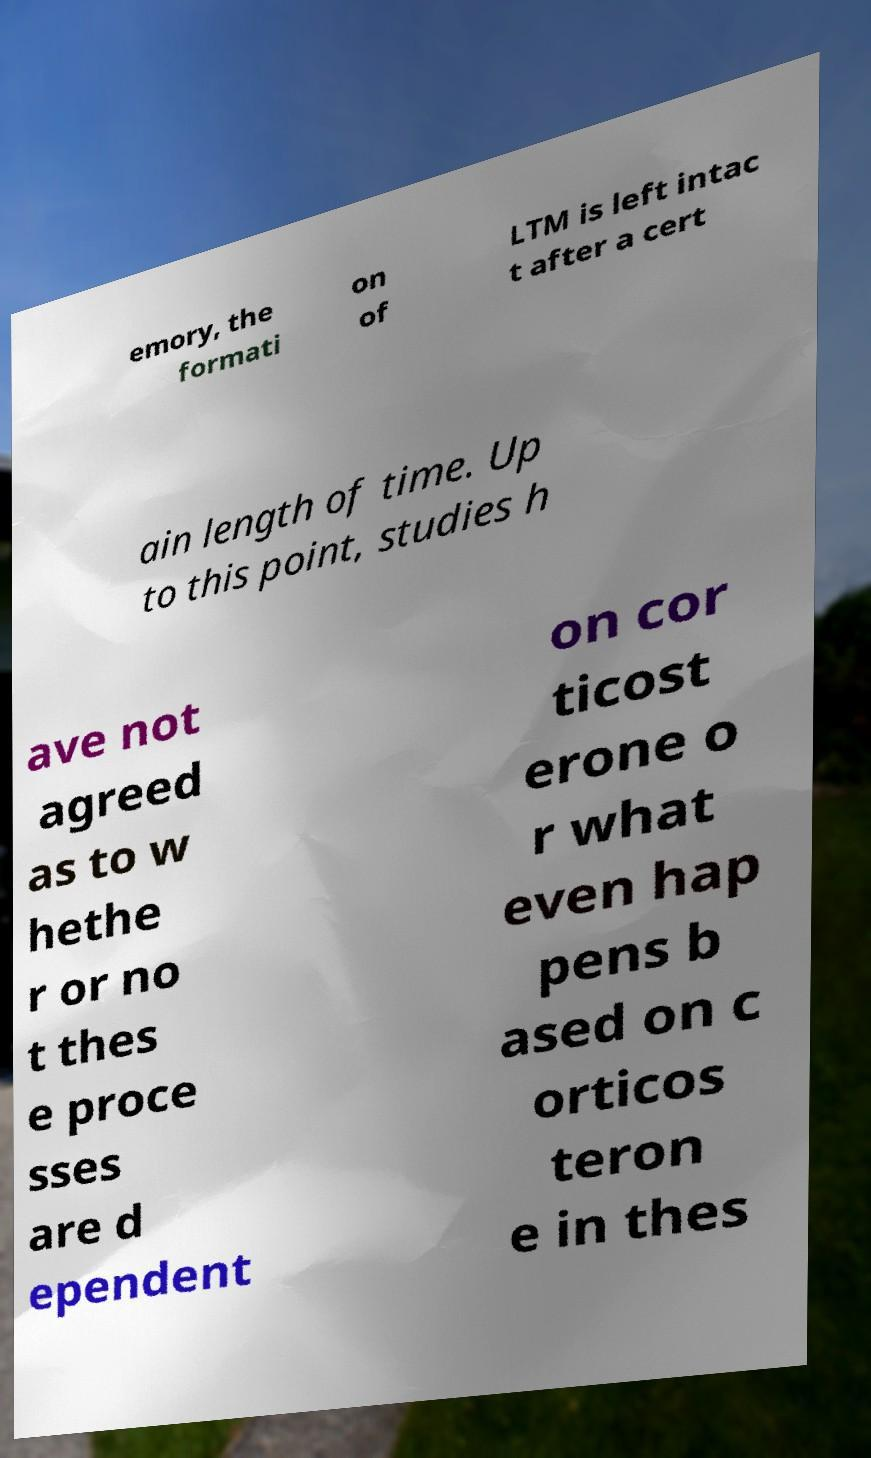Please read and relay the text visible in this image. What does it say? emory, the formati on of LTM is left intac t after a cert ain length of time. Up to this point, studies h ave not agreed as to w hethe r or no t thes e proce sses are d ependent on cor ticost erone o r what even hap pens b ased on c orticos teron e in thes 